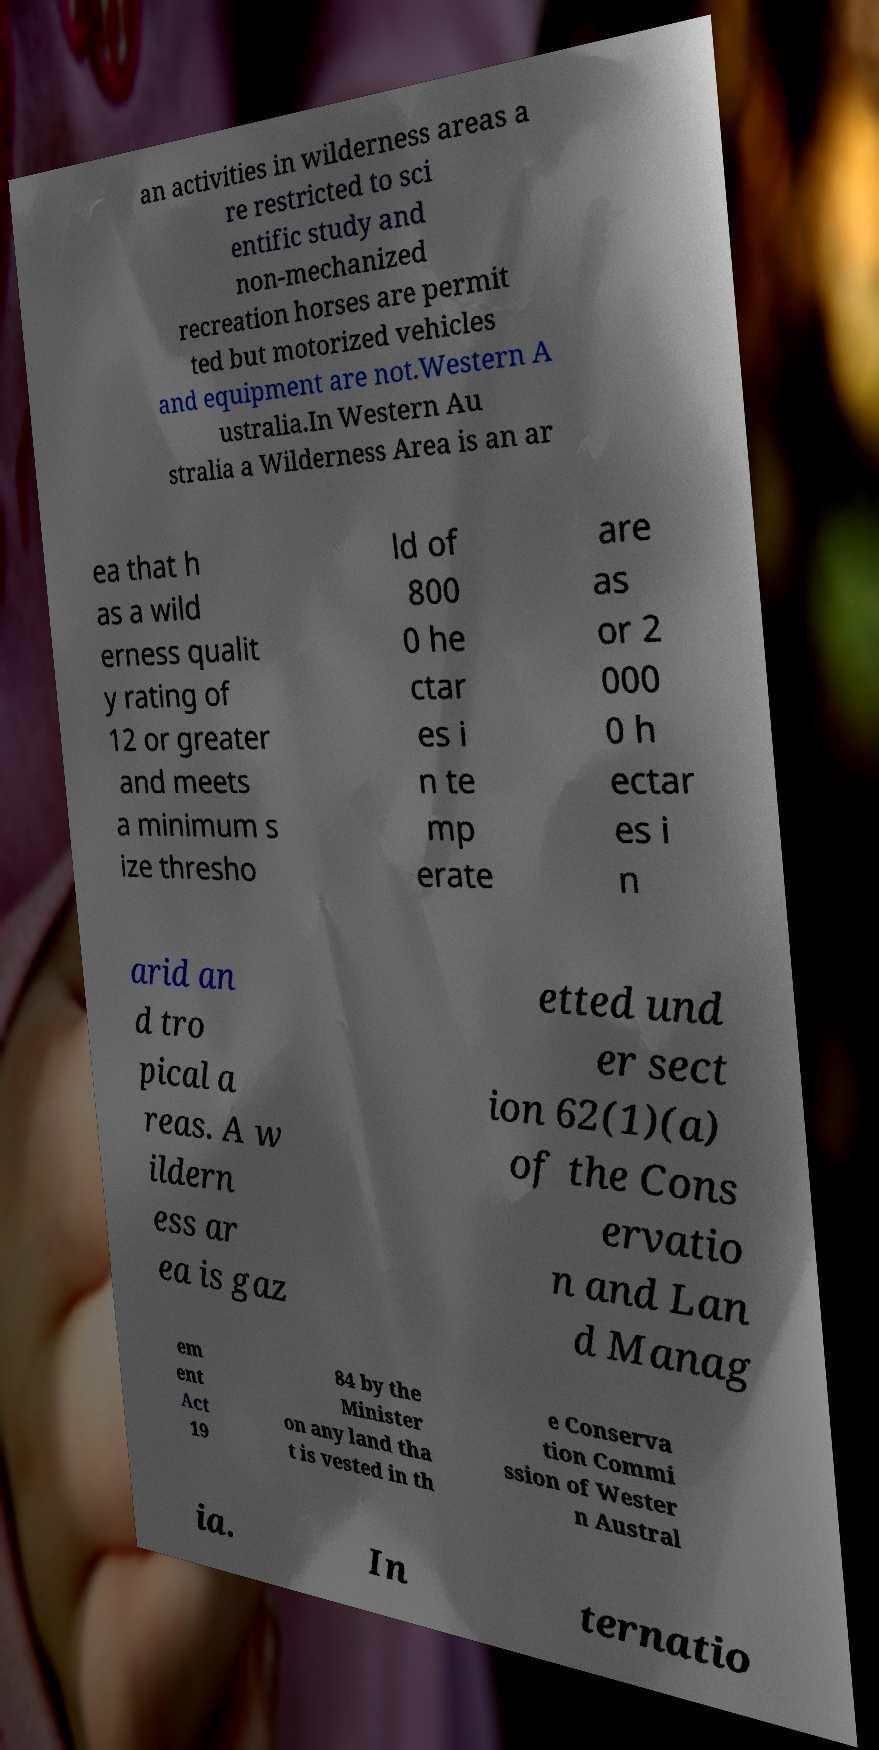Can you read and provide the text displayed in the image?This photo seems to have some interesting text. Can you extract and type it out for me? an activities in wilderness areas a re restricted to sci entific study and non-mechanized recreation horses are permit ted but motorized vehicles and equipment are not.Western A ustralia.In Western Au stralia a Wilderness Area is an ar ea that h as a wild erness qualit y rating of 12 or greater and meets a minimum s ize thresho ld of 800 0 he ctar es i n te mp erate are as or 2 000 0 h ectar es i n arid an d tro pical a reas. A w ildern ess ar ea is gaz etted und er sect ion 62(1)(a) of the Cons ervatio n and Lan d Manag em ent Act 19 84 by the Minister on any land tha t is vested in th e Conserva tion Commi ssion of Wester n Austral ia. In ternatio 